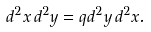Convert formula to latex. <formula><loc_0><loc_0><loc_500><loc_500>d ^ { 2 } x \, d ^ { 2 } y = q d ^ { 2 } y \, d ^ { 2 } x .</formula> 